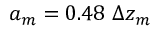Convert formula to latex. <formula><loc_0><loc_0><loc_500><loc_500>a _ { m } = 0 . 4 8 \Delta z _ { m }</formula> 